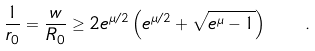<formula> <loc_0><loc_0><loc_500><loc_500>\frac { 1 } { r _ { 0 } } = \frac { w } { R _ { 0 } } \geq 2 e ^ { \mu / 2 } \left ( e ^ { \mu / 2 } + \sqrt { e ^ { \mu } - 1 } \right ) \quad .</formula> 